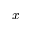<formula> <loc_0><loc_0><loc_500><loc_500>x</formula> 